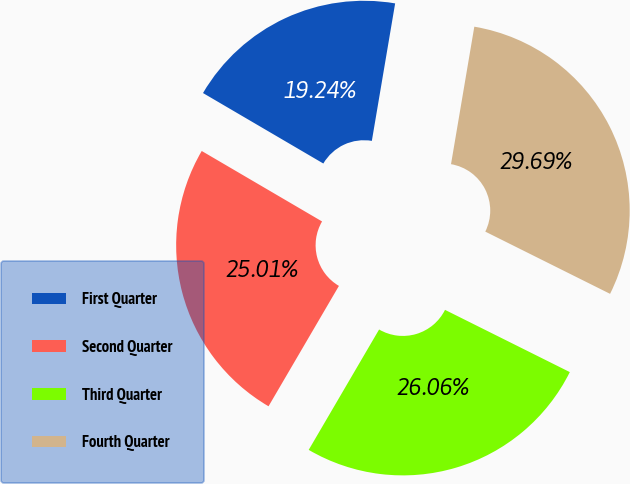<chart> <loc_0><loc_0><loc_500><loc_500><pie_chart><fcel>First Quarter<fcel>Second Quarter<fcel>Third Quarter<fcel>Fourth Quarter<nl><fcel>19.24%<fcel>25.01%<fcel>26.06%<fcel>29.69%<nl></chart> 